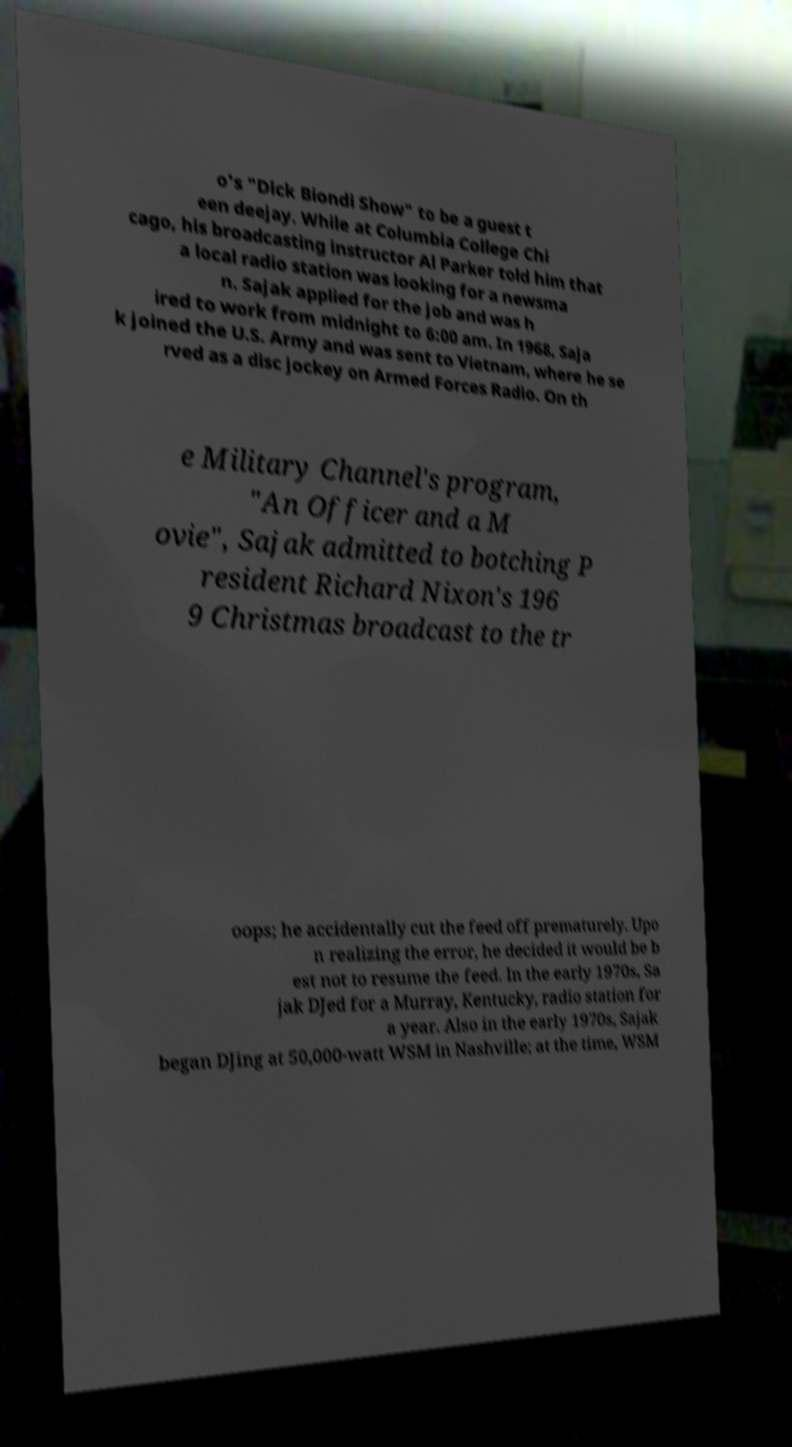Could you extract and type out the text from this image? o's "Dick Biondi Show" to be a guest t een deejay. While at Columbia College Chi cago, his broadcasting instructor Al Parker told him that a local radio station was looking for a newsma n. Sajak applied for the job and was h ired to work from midnight to 6:00 am. In 1968, Saja k joined the U.S. Army and was sent to Vietnam, where he se rved as a disc jockey on Armed Forces Radio. On th e Military Channel's program, "An Officer and a M ovie", Sajak admitted to botching P resident Richard Nixon's 196 9 Christmas broadcast to the tr oops; he accidentally cut the feed off prematurely. Upo n realizing the error, he decided it would be b est not to resume the feed. In the early 1970s, Sa jak DJed for a Murray, Kentucky, radio station for a year. Also in the early 1970s, Sajak began DJing at 50,000-watt WSM in Nashville; at the time, WSM 